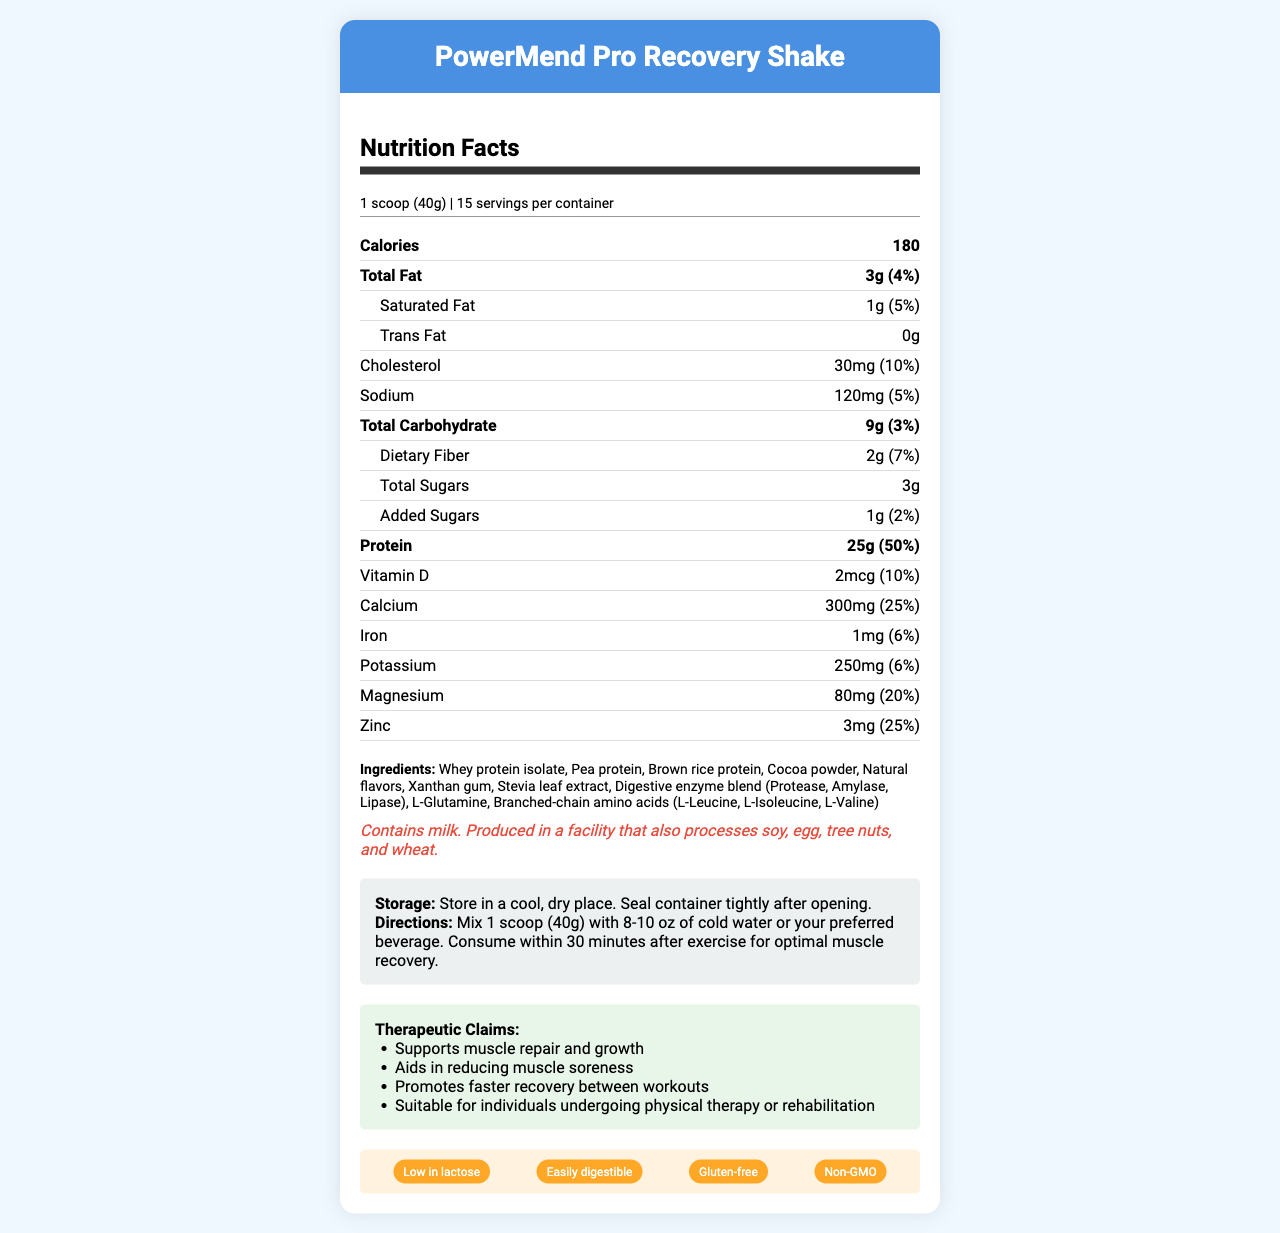what is the serving size? The serving size is stated as "1 scoop (40g)" in the document.
Answer: 1 scoop (40g) how many servings are there per container? The document mentions there are 15 servings per container.
Answer: 15 what are the total calories per serving? The document lists total calories per serving as 180.
Answer: 180 how much protein is in each serving? The amount of protein per serving is listed as "25g" in the document.
Answer: 25g what percentage of the daily value of calcium does one serving provide? The document states that one serving provides 25% of the daily value of calcium.
Answer: 25% which allergen is specifically mentioned in the product? A. Soy B. Milk C. Tree nuts D. Wheat The allergen information mentions "Contains milk."
Answer: B how much dietary fiber is in each serving? The document indicates "Dietary Fiber: 2g".
Answer: 2g does the product contain any trans fat? The document states that the product has "0g" trans fat.
Answer: No what is the main purpose of PowerMend Pro Recovery Shake? The therapeutic claims include "Supports muscle repair and growth."
Answer: Supports muscle repair and growth which ingredients are listed as the main proteins in the product? A. Whey protein isolate, Pea protein, Brown rice protein B. Cocoa powder, Natural flavors, Xanthan gum C. Stevia leaf extract, Digestive enzyme blend, L-Glutamine The main proteins listed are "Whey protein isolate, Pea protein, Brown rice protein."
Answer: A what additional claims does the product make? The document lists additional claims including "Low in lactose, Easily digestible, Gluten-free, Non-GMO."
Answer: Low in lactose, Easily digestible, Gluten-free, Non-GMO how should the product be stored? The storage instructions are to "Store in a cool, dry place. Seal container tightly after opening."
Answer: In a cool, dry place, sealed tightly after opening describe the main components and nutrients in PowerMend Pro Recovery Shake. The document details PowerMend Pro Recovery Shake's nutritional content, therapeutic claims, maintaining muscle repair, low lactose content, and other unique points.
Answer: PowerMend Pro Recovery Shake provides high protein (25g) and various other nutrients like vitamins and minerals. It supports muscle repair and is suitable for post-workout recovery. It also includes ingredients to aid with digestion and additional therapeutic claims. can the amount of natural flavors in the product be determined? The document lists "Natural flavors" as an ingredient, but does not quantify the amount.
Answer: Cannot be determined 